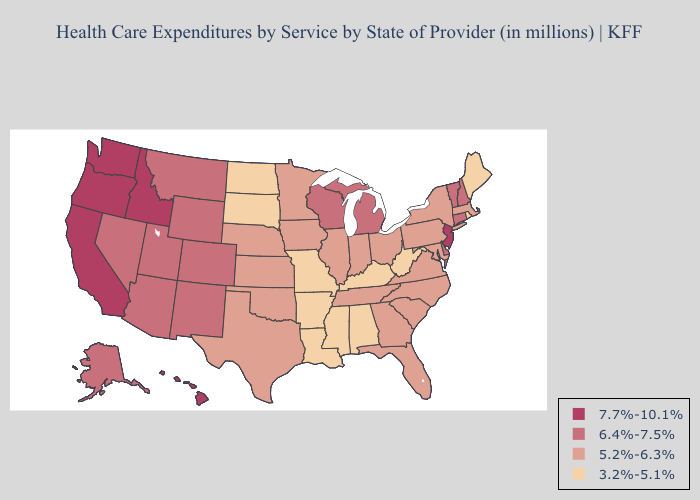Is the legend a continuous bar?
Concise answer only. No. Name the states that have a value in the range 6.4%-7.5%?
Give a very brief answer. Alaska, Arizona, Colorado, Connecticut, Delaware, Michigan, Montana, Nevada, New Hampshire, New Mexico, Utah, Vermont, Wisconsin, Wyoming. Does Indiana have the highest value in the USA?
Write a very short answer. No. Does Florida have a higher value than Vermont?
Short answer required. No. Name the states that have a value in the range 3.2%-5.1%?
Write a very short answer. Alabama, Arkansas, Kentucky, Louisiana, Maine, Mississippi, Missouri, North Dakota, Rhode Island, South Dakota, West Virginia. What is the highest value in the MidWest ?
Quick response, please. 6.4%-7.5%. Does the first symbol in the legend represent the smallest category?
Keep it brief. No. Does West Virginia have a lower value than Alabama?
Concise answer only. No. How many symbols are there in the legend?
Write a very short answer. 4. What is the value of Michigan?
Short answer required. 6.4%-7.5%. What is the value of Connecticut?
Be succinct. 6.4%-7.5%. What is the lowest value in the West?
Be succinct. 6.4%-7.5%. Does Minnesota have the lowest value in the MidWest?
Quick response, please. No. What is the value of Minnesota?
Give a very brief answer. 5.2%-6.3%. What is the lowest value in the Northeast?
Quick response, please. 3.2%-5.1%. 